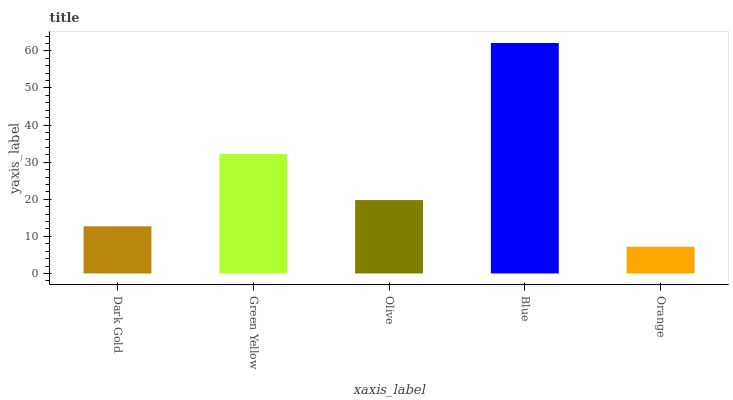Is Orange the minimum?
Answer yes or no. Yes. Is Blue the maximum?
Answer yes or no. Yes. Is Green Yellow the minimum?
Answer yes or no. No. Is Green Yellow the maximum?
Answer yes or no. No. Is Green Yellow greater than Dark Gold?
Answer yes or no. Yes. Is Dark Gold less than Green Yellow?
Answer yes or no. Yes. Is Dark Gold greater than Green Yellow?
Answer yes or no. No. Is Green Yellow less than Dark Gold?
Answer yes or no. No. Is Olive the high median?
Answer yes or no. Yes. Is Olive the low median?
Answer yes or no. Yes. Is Blue the high median?
Answer yes or no. No. Is Orange the low median?
Answer yes or no. No. 